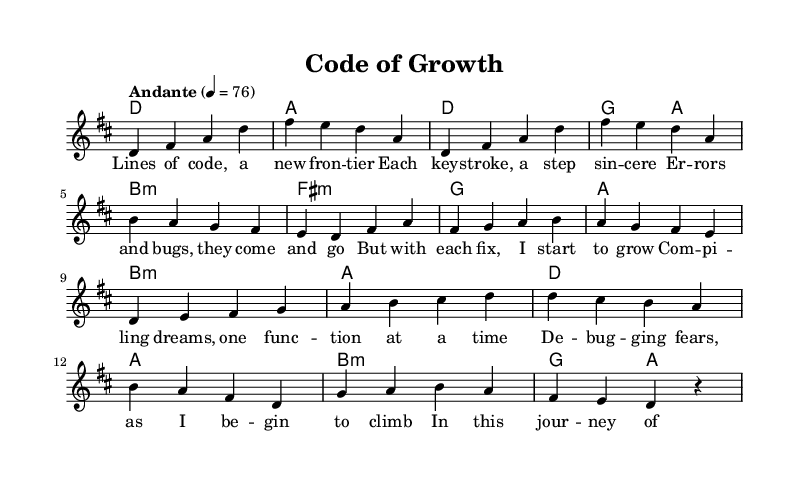What is the key signature of this music? The key signature is D major, which has two sharps: F sharp and C sharp.
Answer: D major What is the time signature of this piece? The time signature is 4/4, indicating that there are four beats in each measure and the quarter note receives one beat.
Answer: 4/4 What is the tempo marking provided for this music? The tempo marking is "Andante," which suggests a moderate pace, generally considered to be between 76 to 108 beats per minute.
Answer: Andante How many measures are in the chorus section? The chorus contains four measures, as indicated by the grouping of notes and the structure of the lyrics in that part.
Answer: Four What emotional theme does the pre-chorus convey? The pre-chorus discusses overcoming fears and compiling dreams, illustrating the emotional struggle and determination involved in personal growth.
Answer: Overcoming fears Which musical section contains lyrics about coding? The verse section contains lyrics that talk about coding, highlighting the experiences associated with learning to code.
Answer: Verse What type of harmonies are used in the pre-chorus? The harmonies in the pre-chorus are mostly built on major chords, except for one minor chord, which helps to convey an uplifting mood despite the challenges discussed.
Answer: Major and minor chords 